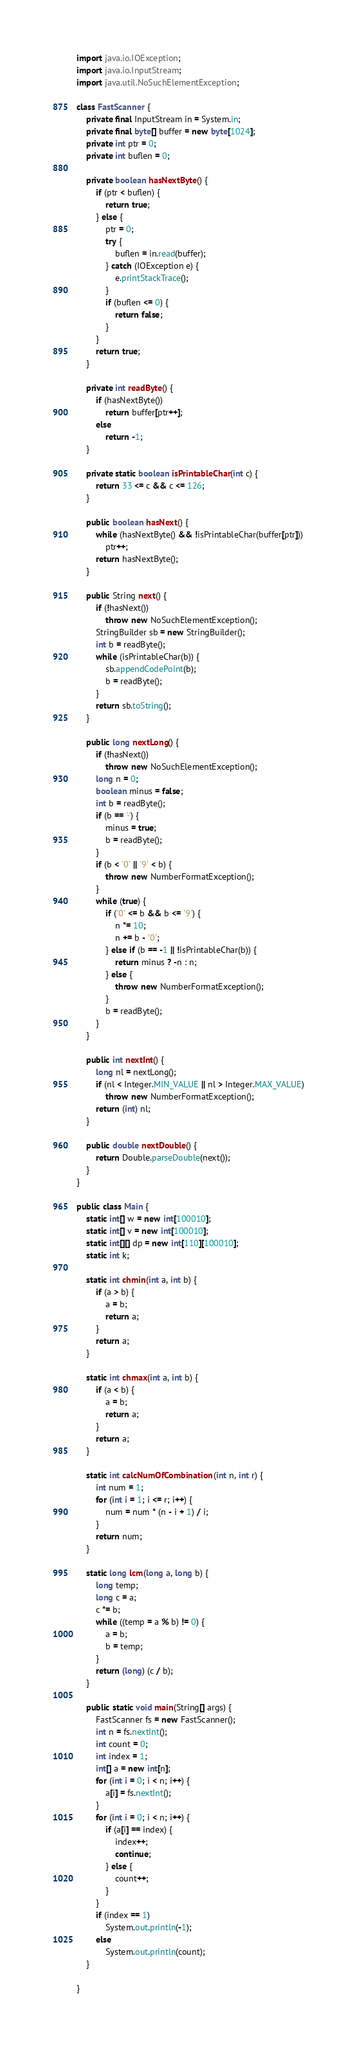<code> <loc_0><loc_0><loc_500><loc_500><_Java_>import java.io.IOException;
import java.io.InputStream;
import java.util.NoSuchElementException;

class FastScanner {
    private final InputStream in = System.in;
    private final byte[] buffer = new byte[1024];
    private int ptr = 0;
    private int buflen = 0;

    private boolean hasNextByte() {
        if (ptr < buflen) {
            return true;
        } else {
            ptr = 0;
            try {
                buflen = in.read(buffer);
            } catch (IOException e) {
                e.printStackTrace();
            }
            if (buflen <= 0) {
                return false;
            }
        }
        return true;
    }

    private int readByte() {
        if (hasNextByte())
            return buffer[ptr++];
        else
            return -1;
    }

    private static boolean isPrintableChar(int c) {
        return 33 <= c && c <= 126;
    }

    public boolean hasNext() {
        while (hasNextByte() && !isPrintableChar(buffer[ptr]))
            ptr++;
        return hasNextByte();
    }

    public String next() {
        if (!hasNext())
            throw new NoSuchElementException();
        StringBuilder sb = new StringBuilder();
        int b = readByte();
        while (isPrintableChar(b)) {
            sb.appendCodePoint(b);
            b = readByte();
        }
        return sb.toString();
    }

    public long nextLong() {
        if (!hasNext())
            throw new NoSuchElementException();
        long n = 0;
        boolean minus = false;
        int b = readByte();
        if (b == '-') {
            minus = true;
            b = readByte();
        }
        if (b < '0' || '9' < b) {
            throw new NumberFormatException();
        }
        while (true) {
            if ('0' <= b && b <= '9') {
                n *= 10;
                n += b - '0';
            } else if (b == -1 || !isPrintableChar(b)) {
                return minus ? -n : n;
            } else {
                throw new NumberFormatException();
            }
            b = readByte();
        }
    }

    public int nextInt() {
        long nl = nextLong();
        if (nl < Integer.MIN_VALUE || nl > Integer.MAX_VALUE)
            throw new NumberFormatException();
        return (int) nl;
    }

    public double nextDouble() {
        return Double.parseDouble(next());
    }
}

public class Main {
    static int[] w = new int[100010];
    static int[] v = new int[100010];
    static int[][] dp = new int[110][100010];
    static int k;

    static int chmin(int a, int b) {
        if (a > b) {
            a = b;
            return a;
        }
        return a;
    }

    static int chmax(int a, int b) {
        if (a < b) {
            a = b;
            return a;
        }
        return a;
    }

    static int calcNumOfCombination(int n, int r) {
        int num = 1;
        for (int i = 1; i <= r; i++) {
            num = num * (n - i + 1) / i;
        }
        return num;
    }

    static long lcm(long a, long b) {
        long temp;
        long c = a;
        c *= b;
        while ((temp = a % b) != 0) {
            a = b;
            b = temp;
        }
        return (long) (c / b);
    }

    public static void main(String[] args) {
        FastScanner fs = new FastScanner();
        int n = fs.nextInt();
        int count = 0;
        int index = 1;
        int[] a = new int[n];
        for (int i = 0; i < n; i++) {
            a[i] = fs.nextInt();
        }
        for (int i = 0; i < n; i++) {
            if (a[i] == index) {
                index++;
                continue;
            } else {
                count++;
            }
        }
        if (index == 1)
            System.out.println(-1);
        else
            System.out.println(count);
    }

}
</code> 